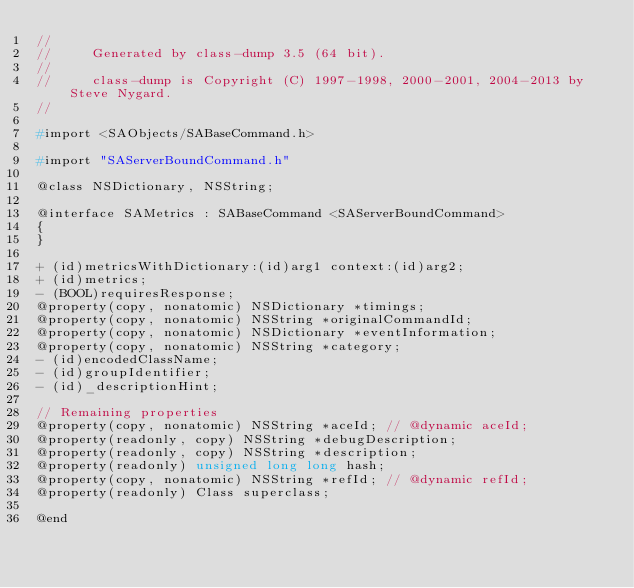<code> <loc_0><loc_0><loc_500><loc_500><_C_>//
//     Generated by class-dump 3.5 (64 bit).
//
//     class-dump is Copyright (C) 1997-1998, 2000-2001, 2004-2013 by Steve Nygard.
//

#import <SAObjects/SABaseCommand.h>

#import "SAServerBoundCommand.h"

@class NSDictionary, NSString;

@interface SAMetrics : SABaseCommand <SAServerBoundCommand>
{
}

+ (id)metricsWithDictionary:(id)arg1 context:(id)arg2;
+ (id)metrics;
- (BOOL)requiresResponse;
@property(copy, nonatomic) NSDictionary *timings;
@property(copy, nonatomic) NSString *originalCommandId;
@property(copy, nonatomic) NSDictionary *eventInformation;
@property(copy, nonatomic) NSString *category;
- (id)encodedClassName;
- (id)groupIdentifier;
- (id)_descriptionHint;

// Remaining properties
@property(copy, nonatomic) NSString *aceId; // @dynamic aceId;
@property(readonly, copy) NSString *debugDescription;
@property(readonly, copy) NSString *description;
@property(readonly) unsigned long long hash;
@property(copy, nonatomic) NSString *refId; // @dynamic refId;
@property(readonly) Class superclass;

@end

</code> 